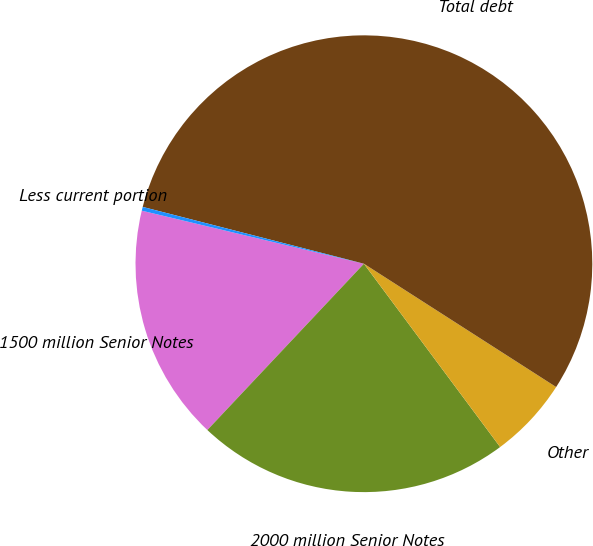<chart> <loc_0><loc_0><loc_500><loc_500><pie_chart><fcel>1500 million Senior Notes<fcel>2000 million Senior Notes<fcel>Other<fcel>Total debt<fcel>Less current portion<nl><fcel>16.71%<fcel>22.19%<fcel>5.75%<fcel>55.07%<fcel>0.27%<nl></chart> 